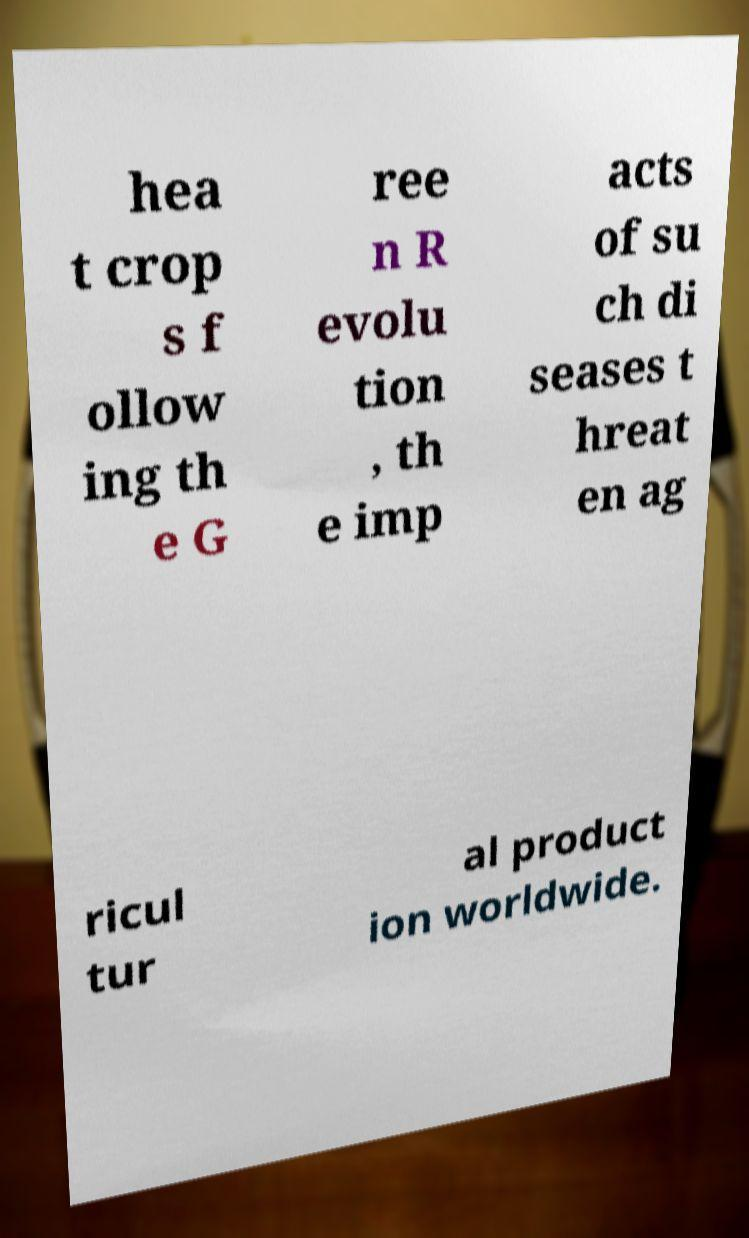Could you extract and type out the text from this image? hea t crop s f ollow ing th e G ree n R evolu tion , th e imp acts of su ch di seases t hreat en ag ricul tur al product ion worldwide. 